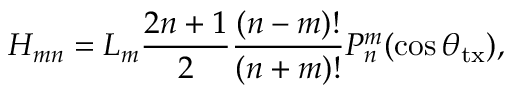<formula> <loc_0><loc_0><loc_500><loc_500>H _ { m n } = L _ { m } \frac { 2 n + 1 } { 2 } \frac { ( n - m ) ! } { ( n + m ) ! } P _ { n } ^ { m } ( \cos \theta _ { t x } ) ,</formula> 